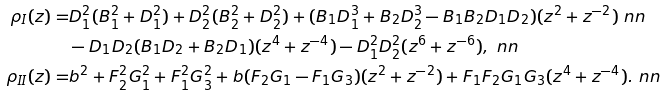<formula> <loc_0><loc_0><loc_500><loc_500>\rho _ { I } ( z ) = & D _ { 1 } ^ { 2 } ( B _ { 1 } ^ { 2 } + D _ { 1 } ^ { 2 } ) + D _ { 2 } ^ { 2 } ( B _ { 2 } ^ { 2 } + D _ { 2 } ^ { 2 } ) + ( B _ { 1 } D _ { 1 } ^ { 3 } + B _ { 2 } D _ { 2 } ^ { 3 } - B _ { 1 } B _ { 2 } D _ { 1 } D _ { 2 } ) ( z ^ { 2 } + z ^ { - 2 } ) \ n n \\ & - D _ { 1 } D _ { 2 } ( B _ { 1 } D _ { 2 } + B _ { 2 } D _ { 1 } ) ( z ^ { 4 } + z ^ { - 4 } ) - D _ { 1 } ^ { 2 } D _ { 2 } ^ { 2 } ( z ^ { 6 } + z ^ { - 6 } ) , \ n n \\ \rho _ { I I } ( z ) = & b ^ { 2 } + F _ { 2 } ^ { 2 } G _ { 1 } ^ { 2 } + F _ { 1 } ^ { 2 } G _ { 3 } ^ { 2 } + b ( F _ { 2 } G _ { 1 } - F _ { 1 } G _ { 3 } ) ( z ^ { 2 } + z ^ { - 2 } ) + F _ { 1 } F _ { 2 } G _ { 1 } G _ { 3 } ( z ^ { 4 } + z ^ { - 4 } ) . \ n n</formula> 